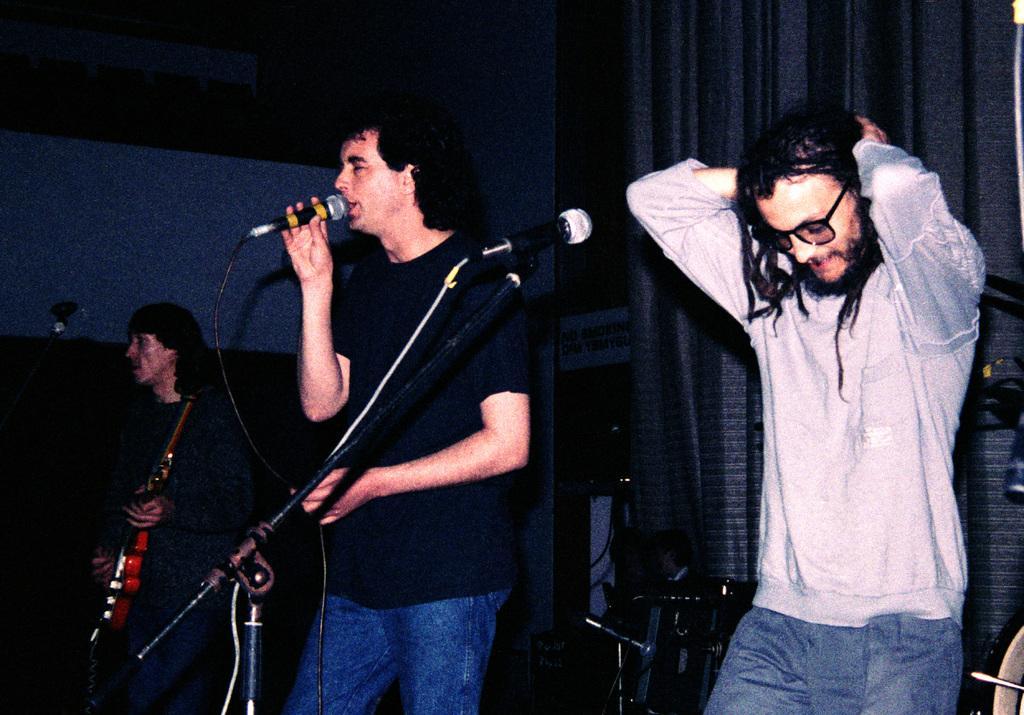Could you give a brief overview of what you see in this image? there are three persons two persons are sitting in a microphone and one person is playing guitar 